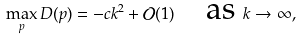Convert formula to latex. <formula><loc_0><loc_0><loc_500><loc_500>\max _ { p } D ( p ) = - c k ^ { 2 } + \mathcal { O } ( 1 ) \quad \text {as } k \rightarrow \infty ,</formula> 